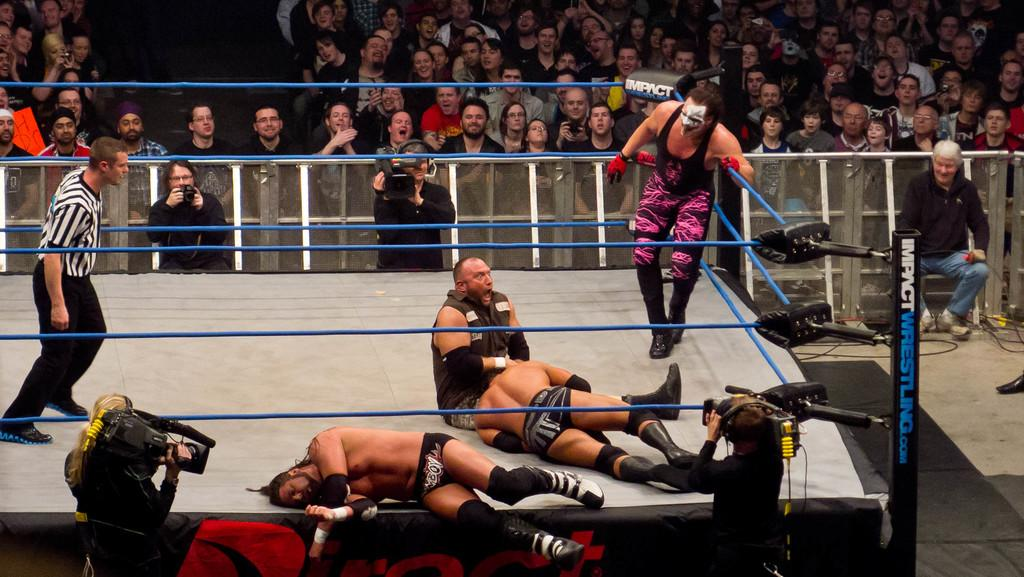Provide a one-sentence caption for the provided image. A wrestling ring displays the name Impact Wrestling on it in several places. 